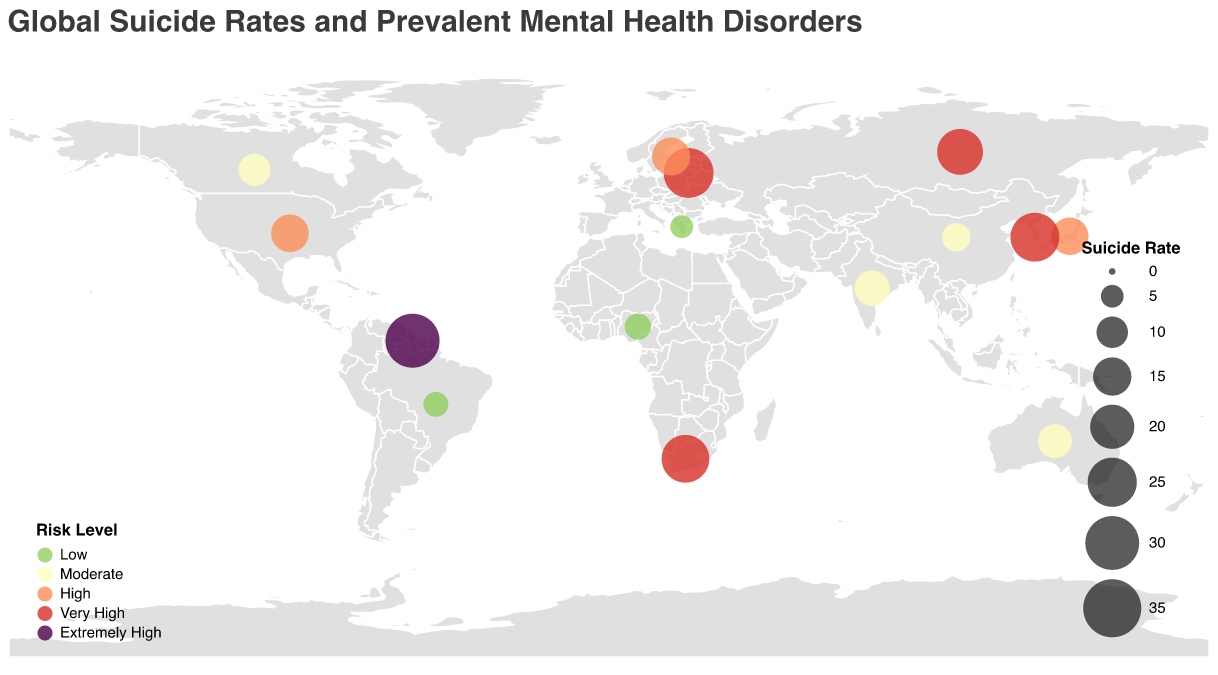Which country has the highest suicide rate? From the data in the figure, Guyana has the highest suicide rate of 30.2.
Answer: Guyana Which countries fall under the "Very High" risk level and what are their suicide rates? The countries categorized under "Very High" risk level are South Korea with a suicide rate of 24.6, Russia with a suicide rate of 21.6, Lithuania with a suicide rate of 25.7, and South Africa with a suicide rate of 23.5.
Answer: South Korea (24.6), Russia (21.6), Lithuania (25.7), South Africa (23.5) Identify the countries with a "Moderate" risk level. What are the prevalent disorders in those countries? The countries with a "Moderate" risk level are India (Schizophrenia), Australia (Bipolar disorder), China (Generalized anxiety disorder), and Canada (ADHD).
Answer: India (Schizophrenia), Australia (Bipolar disorder), China (Generalized anxiety disorder), Canada (ADHD) Compare the suicide rates of Japan and the United States. Which country has a higher rate, and by how much? Japan has a suicide rate of 14.3, and the United States has a suicide rate of 14.5. The United States has a slightly higher rate than Japan by 0.2.
Answer: United States by 0.2 What primary treatment approach is used in Sweden for its prevalent disorder, and what is the risk level of the country? In Sweden, the primary treatment approach for OCD is Exposure and Response Prevention, and the country falls under the "High" risk level.
Answer: Exposure and Response Prevention, High Which country has the lowest suicide rate, and what is the prevalent mental health disorder there? Greece has the lowest suicide rate at 5.0, and the prevalent disorder is Eating disorders.
Answer: Greece, Eating disorders What are the primary treatment approaches in countries with "Low" risk level? The primary treatment approaches in countries with "Low" risk level are Nutritional counseling and psychotherapy in Greece, Dialectical behavior therapy in Brazil, and Cultural competence in mental health care in Nigeria.
Answer: Nutritional counseling and psychotherapy (Greece), Dialectical behavior therapy (Brazil), Cultural competence in mental health care (Nigeria) On average, what is the suicide rate of the countries classified as "Very High" risk? The countries classified as "Very High" risk are South Korea (24.6), Russia (21.6), Lithuania (25.7), and South Africa (23.5). Sum these rates: 24.6 + 21.6 + 25.7 + 23.5 = 95.4. There are 4 countries, so the average is 95.4 / 4 = 23.85.
Answer: 23.85 Among the countries with "Moderate" risk level, which has the highest suicide rate, and what is it? India has the highest suicide rate among the "Moderate" risk level countries with a rate of 12.7.
Answer: India, 12.7 How many countries in total are depicted in the figure? The data lists 14 countries, each represented as a data point on the plot.
Answer: 14 